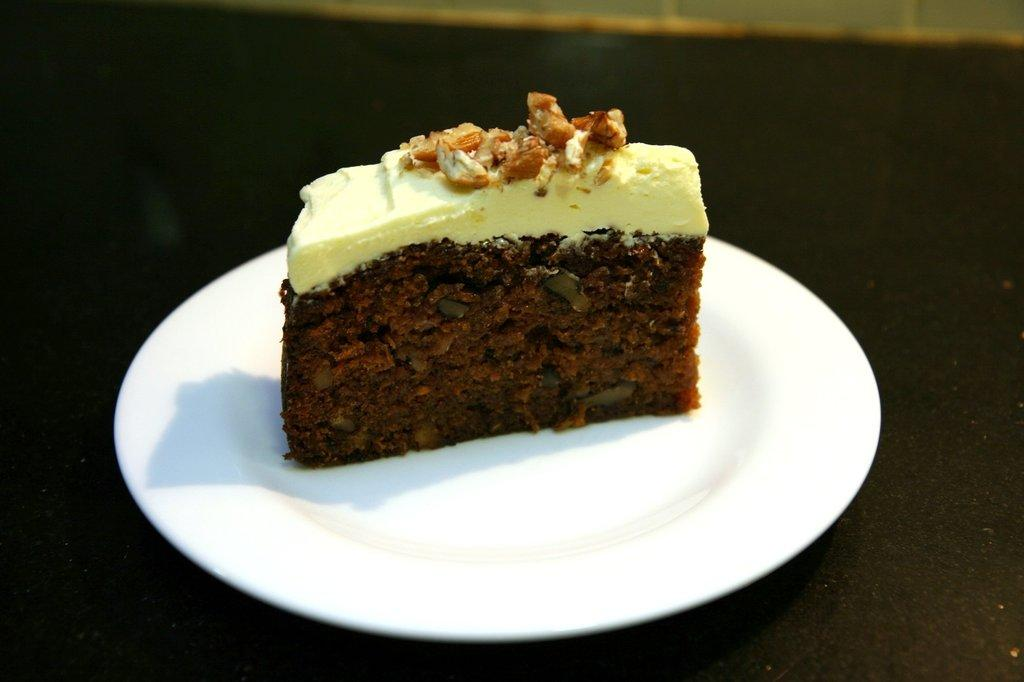What type of dessert is visible in the image? There is a chocolate cake in the image. How is the cake presented? The cake is on a plate. Where is the plate with the cake located? The plate with the cake is on a table. Can you describe the background of the image? There might be a wall visible at the top of the image. What type of vacation is being suggested in the image? There is no suggestion of a vacation in the image; it features a chocolate cake on a plate. What downtown area can be seen in the image? There is no downtown area present in the image; it features a chocolate cake on a plate. 